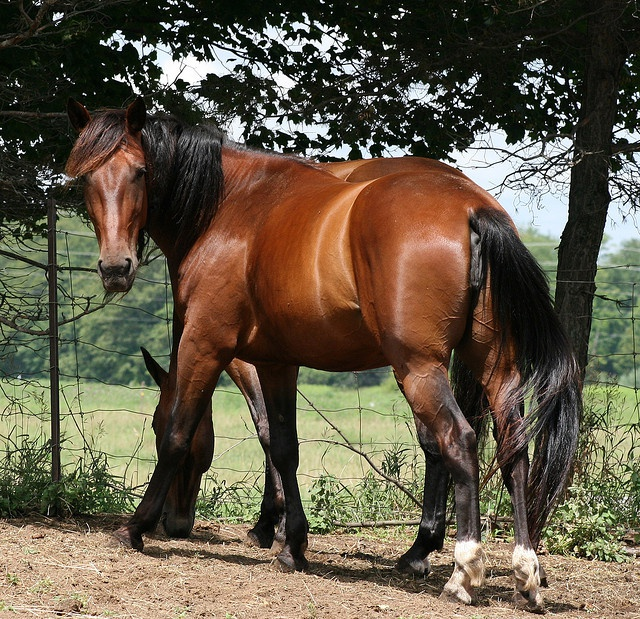Describe the objects in this image and their specific colors. I can see horse in black, maroon, and brown tones and horse in black, gray, darkgray, and beige tones in this image. 